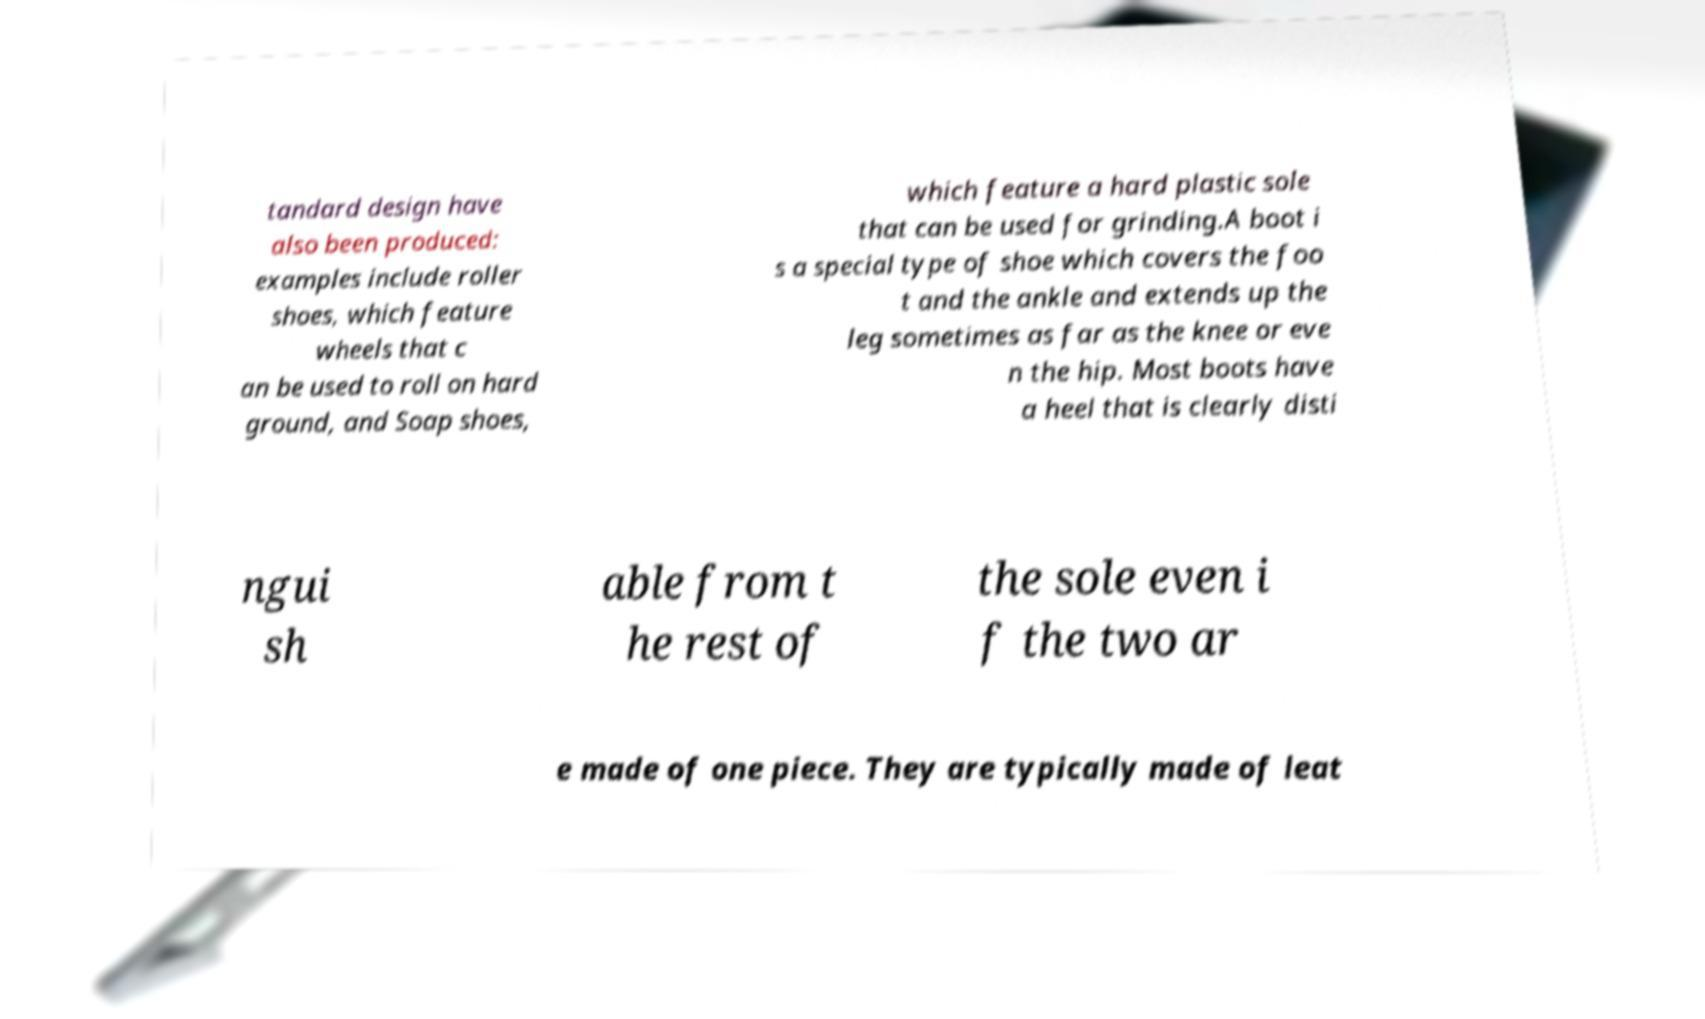Please identify and transcribe the text found in this image. tandard design have also been produced: examples include roller shoes, which feature wheels that c an be used to roll on hard ground, and Soap shoes, which feature a hard plastic sole that can be used for grinding.A boot i s a special type of shoe which covers the foo t and the ankle and extends up the leg sometimes as far as the knee or eve n the hip. Most boots have a heel that is clearly disti ngui sh able from t he rest of the sole even i f the two ar e made of one piece. They are typically made of leat 